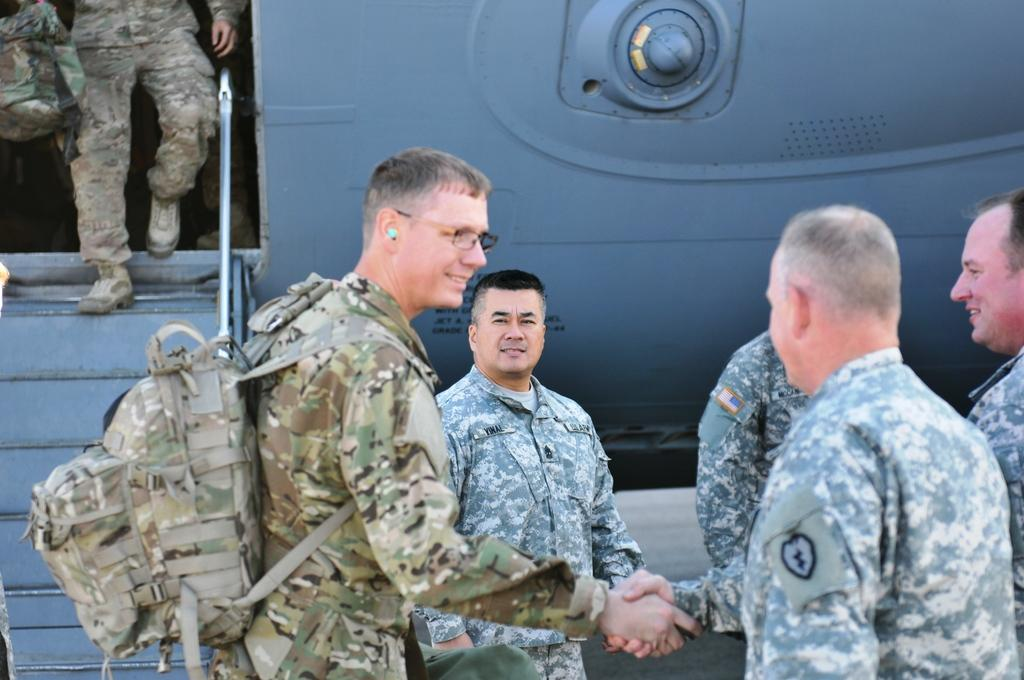What are the two men in the image doing? The two men in the image are shaking hands. What can be seen in the background of the image? There are people standing and an aircraft in the background of the image. What is the man in the background doing? The man in the background is walking on stairs from the aircraft. What type of sign is the man holding in the image? There is no sign present in the image; the man is not holding anything. What is the size of the ground in the image? The image does not provide information about the size of the ground, as it only shows a portion of the scene. 